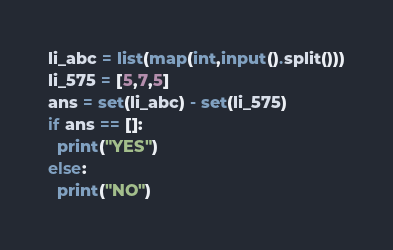<code> <loc_0><loc_0><loc_500><loc_500><_Python_>li_abc = list(map(int,input().split()))
li_575 = [5,7,5]
ans = set(li_abc) - set(li_575)
if ans == []:
  print("YES")
else:
  print("NO")</code> 